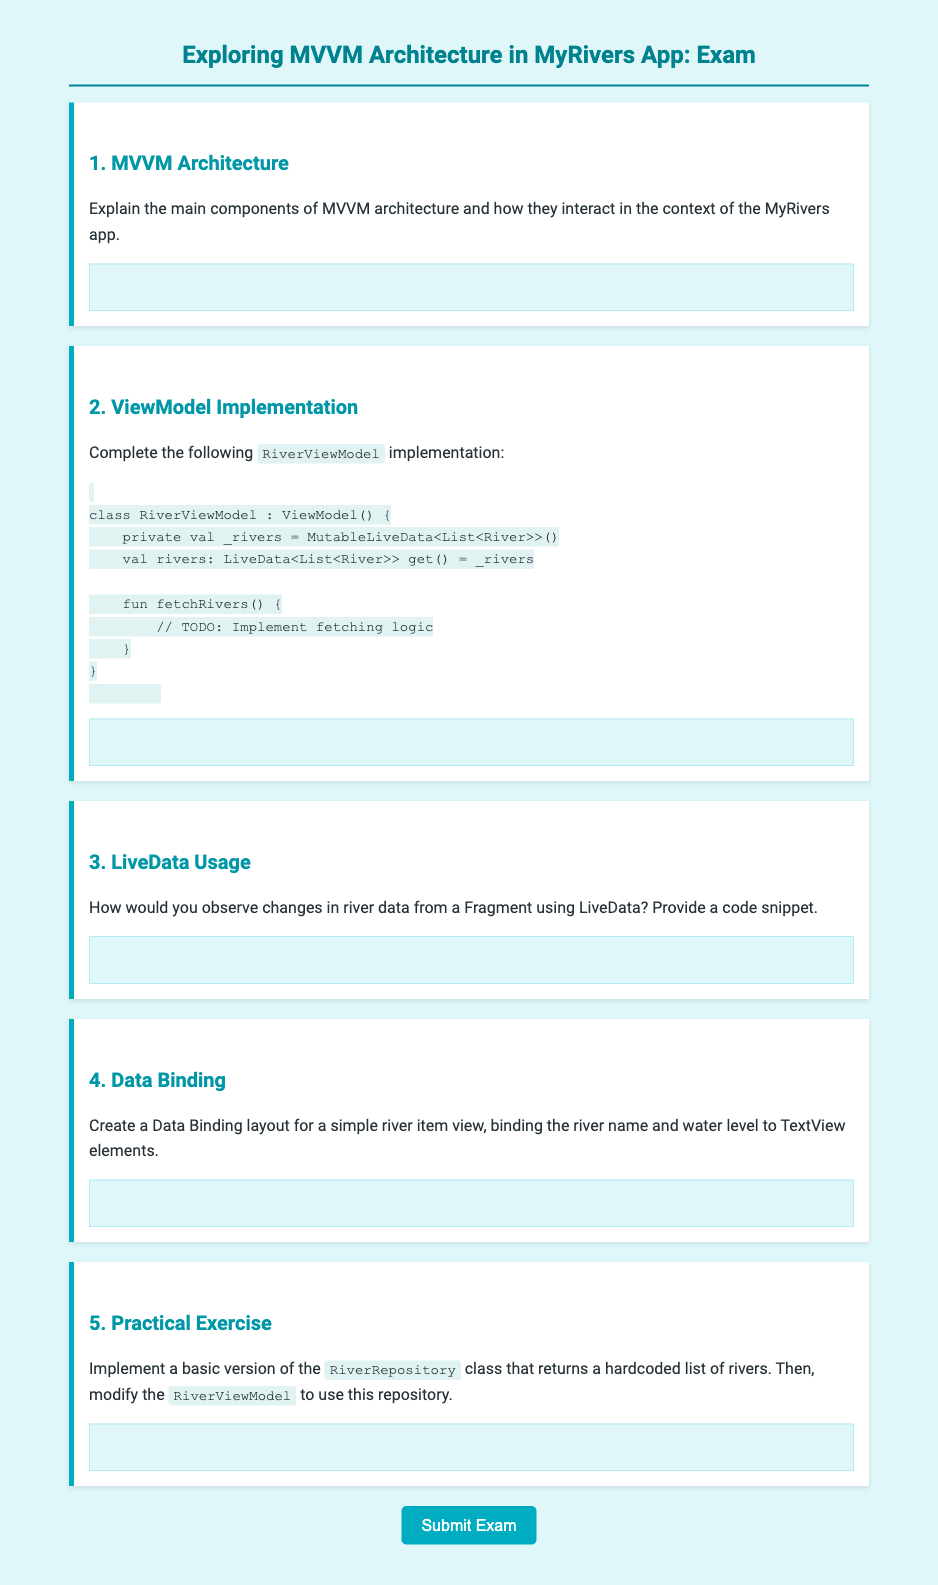What is the title of the document? The title is provided in the <title> tag of the HTML, which describes the content focus of the document.
Answer: MyRivers App MVVM Architecture Exam How many questions are there in the exam? The exam contains several main questions that cover different aspects of MVVM architecture.
Answer: 5 What component is predominantly discussed in the exam? The exam revolves around a specific design pattern in Android development that separates concerns among components.
Answer: MVVM Architecture What class needs to be completed in question 2? The class mentioned in question 2 relates to the management of river data in the app architecture.
Answer: RiverViewModel What should be implemented in the RiverViewModel class according to question 2? The task involves adding functionality to retrieve river data within the defined class.
Answer: fetching logic What is the purpose of LiveData according to the document? LiveData is a component that defines a data holder class that can be observed for changes, typically used within ViewModels in Android applications.
Answer: Observe changes What kind of data structure is expected to be returned by the LiveData 'rivers'? The data structure mentioned indicates the type of information that the LiveData will hold, specifically relating to aquatic elements in the app.
Answer: List of River Which UI elements are being bound in question 4? The question refers to specific visual elements within the user interface that display information from the data model.
Answer: TextView elements What class should be implemented as per question 5? The question asks for a class representing a data source handling the river data logic, which provides static information.
Answer: RiverRepository 